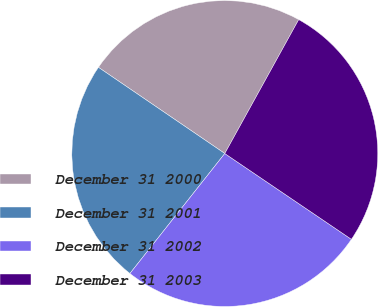<chart> <loc_0><loc_0><loc_500><loc_500><pie_chart><fcel>December 31 2000<fcel>December 31 2001<fcel>December 31 2002<fcel>December 31 2003<nl><fcel>23.5%<fcel>23.88%<fcel>26.17%<fcel>26.45%<nl></chart> 